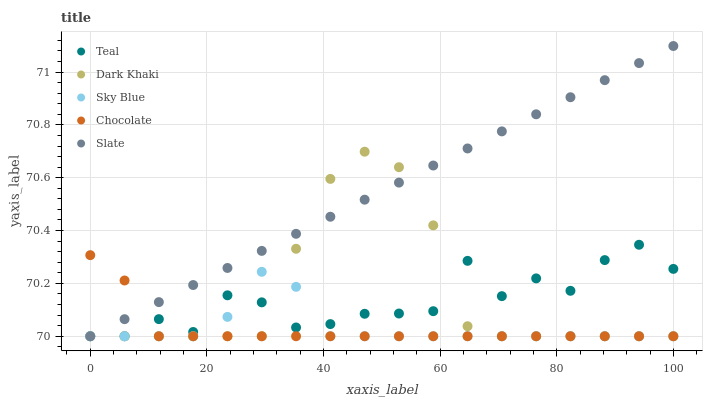Does Chocolate have the minimum area under the curve?
Answer yes or no. Yes. Does Slate have the maximum area under the curve?
Answer yes or no. Yes. Does Sky Blue have the minimum area under the curve?
Answer yes or no. No. Does Sky Blue have the maximum area under the curve?
Answer yes or no. No. Is Slate the smoothest?
Answer yes or no. Yes. Is Teal the roughest?
Answer yes or no. Yes. Is Sky Blue the smoothest?
Answer yes or no. No. Is Sky Blue the roughest?
Answer yes or no. No. Does Dark Khaki have the lowest value?
Answer yes or no. Yes. Does Slate have the highest value?
Answer yes or no. Yes. Does Sky Blue have the highest value?
Answer yes or no. No. Does Slate intersect Chocolate?
Answer yes or no. Yes. Is Slate less than Chocolate?
Answer yes or no. No. Is Slate greater than Chocolate?
Answer yes or no. No. 